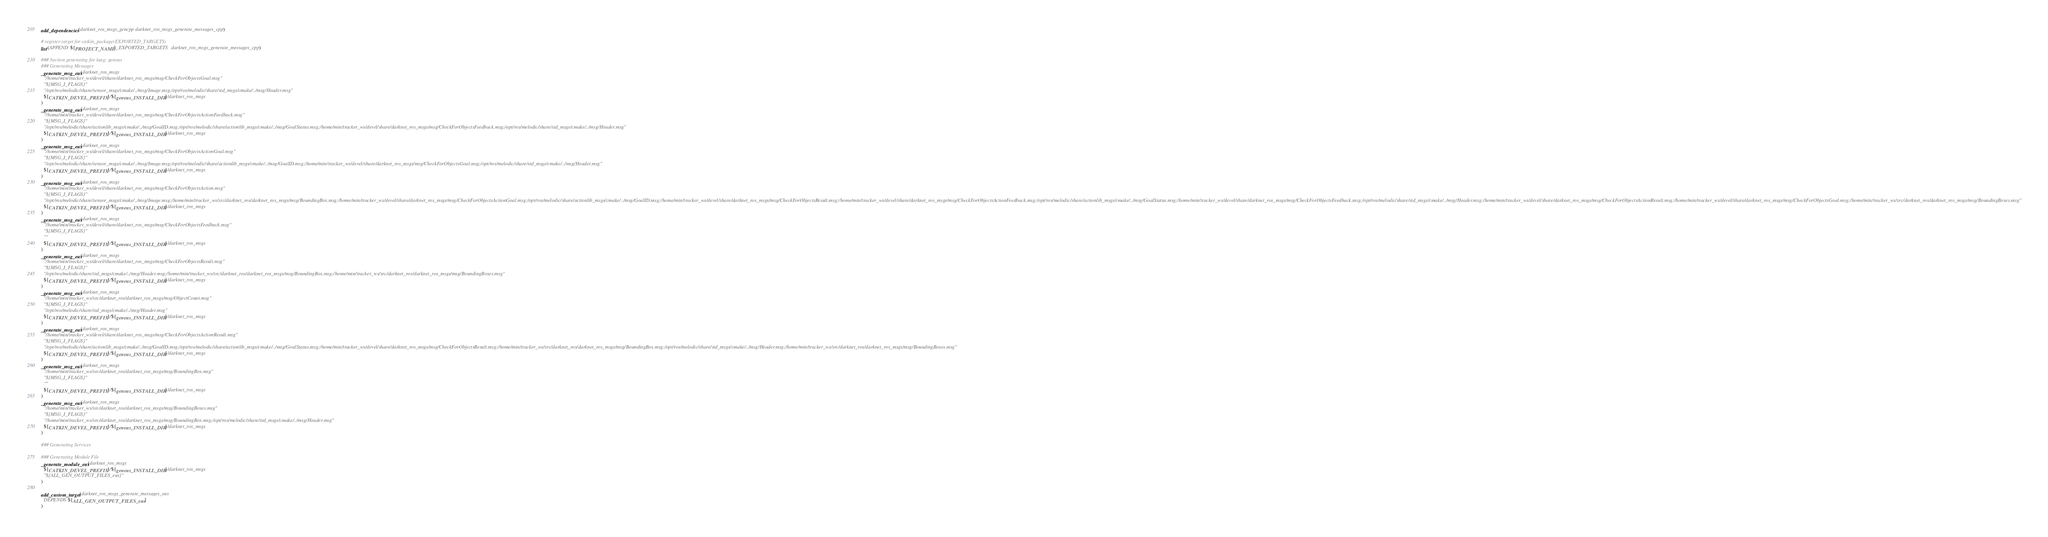Convert code to text. <code><loc_0><loc_0><loc_500><loc_500><_CMake_>add_dependencies(darknet_ros_msgs_gencpp darknet_ros_msgs_generate_messages_cpp)

# register target for catkin_package(EXPORTED_TARGETS)
list(APPEND ${PROJECT_NAME}_EXPORTED_TARGETS darknet_ros_msgs_generate_messages_cpp)

### Section generating for lang: geneus
### Generating Messages
_generate_msg_eus(darknet_ros_msgs
  "/home/min/tracker_ws/devel/share/darknet_ros_msgs/msg/CheckForObjectsGoal.msg"
  "${MSG_I_FLAGS}"
  "/opt/ros/melodic/share/sensor_msgs/cmake/../msg/Image.msg;/opt/ros/melodic/share/std_msgs/cmake/../msg/Header.msg"
  ${CATKIN_DEVEL_PREFIX}/${geneus_INSTALL_DIR}/darknet_ros_msgs
)
_generate_msg_eus(darknet_ros_msgs
  "/home/min/tracker_ws/devel/share/darknet_ros_msgs/msg/CheckForObjectsActionFeedback.msg"
  "${MSG_I_FLAGS}"
  "/opt/ros/melodic/share/actionlib_msgs/cmake/../msg/GoalID.msg;/opt/ros/melodic/share/actionlib_msgs/cmake/../msg/GoalStatus.msg;/home/min/tracker_ws/devel/share/darknet_ros_msgs/msg/CheckForObjectsFeedback.msg;/opt/ros/melodic/share/std_msgs/cmake/../msg/Header.msg"
  ${CATKIN_DEVEL_PREFIX}/${geneus_INSTALL_DIR}/darknet_ros_msgs
)
_generate_msg_eus(darknet_ros_msgs
  "/home/min/tracker_ws/devel/share/darknet_ros_msgs/msg/CheckForObjectsActionGoal.msg"
  "${MSG_I_FLAGS}"
  "/opt/ros/melodic/share/sensor_msgs/cmake/../msg/Image.msg;/opt/ros/melodic/share/actionlib_msgs/cmake/../msg/GoalID.msg;/home/min/tracker_ws/devel/share/darknet_ros_msgs/msg/CheckForObjectsGoal.msg;/opt/ros/melodic/share/std_msgs/cmake/../msg/Header.msg"
  ${CATKIN_DEVEL_PREFIX}/${geneus_INSTALL_DIR}/darknet_ros_msgs
)
_generate_msg_eus(darknet_ros_msgs
  "/home/min/tracker_ws/devel/share/darknet_ros_msgs/msg/CheckForObjectsAction.msg"
  "${MSG_I_FLAGS}"
  "/opt/ros/melodic/share/sensor_msgs/cmake/../msg/Image.msg;/home/min/tracker_ws/src/darknet_ros/darknet_ros_msgs/msg/BoundingBox.msg;/home/min/tracker_ws/devel/share/darknet_ros_msgs/msg/CheckForObjectsActionGoal.msg;/opt/ros/melodic/share/actionlib_msgs/cmake/../msg/GoalID.msg;/home/min/tracker_ws/devel/share/darknet_ros_msgs/msg/CheckForObjectsResult.msg;/home/min/tracker_ws/devel/share/darknet_ros_msgs/msg/CheckForObjectsActionFeedback.msg;/opt/ros/melodic/share/actionlib_msgs/cmake/../msg/GoalStatus.msg;/home/min/tracker_ws/devel/share/darknet_ros_msgs/msg/CheckForObjectsFeedback.msg;/opt/ros/melodic/share/std_msgs/cmake/../msg/Header.msg;/home/min/tracker_ws/devel/share/darknet_ros_msgs/msg/CheckForObjectsActionResult.msg;/home/min/tracker_ws/devel/share/darknet_ros_msgs/msg/CheckForObjectsGoal.msg;/home/min/tracker_ws/src/darknet_ros/darknet_ros_msgs/msg/BoundingBoxes.msg"
  ${CATKIN_DEVEL_PREFIX}/${geneus_INSTALL_DIR}/darknet_ros_msgs
)
_generate_msg_eus(darknet_ros_msgs
  "/home/min/tracker_ws/devel/share/darknet_ros_msgs/msg/CheckForObjectsFeedback.msg"
  "${MSG_I_FLAGS}"
  ""
  ${CATKIN_DEVEL_PREFIX}/${geneus_INSTALL_DIR}/darknet_ros_msgs
)
_generate_msg_eus(darknet_ros_msgs
  "/home/min/tracker_ws/devel/share/darknet_ros_msgs/msg/CheckForObjectsResult.msg"
  "${MSG_I_FLAGS}"
  "/opt/ros/melodic/share/std_msgs/cmake/../msg/Header.msg;/home/min/tracker_ws/src/darknet_ros/darknet_ros_msgs/msg/BoundingBox.msg;/home/min/tracker_ws/src/darknet_ros/darknet_ros_msgs/msg/BoundingBoxes.msg"
  ${CATKIN_DEVEL_PREFIX}/${geneus_INSTALL_DIR}/darknet_ros_msgs
)
_generate_msg_eus(darknet_ros_msgs
  "/home/min/tracker_ws/src/darknet_ros/darknet_ros_msgs/msg/ObjectCount.msg"
  "${MSG_I_FLAGS}"
  "/opt/ros/melodic/share/std_msgs/cmake/../msg/Header.msg"
  ${CATKIN_DEVEL_PREFIX}/${geneus_INSTALL_DIR}/darknet_ros_msgs
)
_generate_msg_eus(darknet_ros_msgs
  "/home/min/tracker_ws/devel/share/darknet_ros_msgs/msg/CheckForObjectsActionResult.msg"
  "${MSG_I_FLAGS}"
  "/opt/ros/melodic/share/actionlib_msgs/cmake/../msg/GoalID.msg;/opt/ros/melodic/share/actionlib_msgs/cmake/../msg/GoalStatus.msg;/home/min/tracker_ws/devel/share/darknet_ros_msgs/msg/CheckForObjectsResult.msg;/home/min/tracker_ws/src/darknet_ros/darknet_ros_msgs/msg/BoundingBox.msg;/opt/ros/melodic/share/std_msgs/cmake/../msg/Header.msg;/home/min/tracker_ws/src/darknet_ros/darknet_ros_msgs/msg/BoundingBoxes.msg"
  ${CATKIN_DEVEL_PREFIX}/${geneus_INSTALL_DIR}/darknet_ros_msgs
)
_generate_msg_eus(darknet_ros_msgs
  "/home/min/tracker_ws/src/darknet_ros/darknet_ros_msgs/msg/BoundingBox.msg"
  "${MSG_I_FLAGS}"
  ""
  ${CATKIN_DEVEL_PREFIX}/${geneus_INSTALL_DIR}/darknet_ros_msgs
)
_generate_msg_eus(darknet_ros_msgs
  "/home/min/tracker_ws/src/darknet_ros/darknet_ros_msgs/msg/BoundingBoxes.msg"
  "${MSG_I_FLAGS}"
  "/home/min/tracker_ws/src/darknet_ros/darknet_ros_msgs/msg/BoundingBox.msg;/opt/ros/melodic/share/std_msgs/cmake/../msg/Header.msg"
  ${CATKIN_DEVEL_PREFIX}/${geneus_INSTALL_DIR}/darknet_ros_msgs
)

### Generating Services

### Generating Module File
_generate_module_eus(darknet_ros_msgs
  ${CATKIN_DEVEL_PREFIX}/${geneus_INSTALL_DIR}/darknet_ros_msgs
  "${ALL_GEN_OUTPUT_FILES_eus}"
)

add_custom_target(darknet_ros_msgs_generate_messages_eus
  DEPENDS ${ALL_GEN_OUTPUT_FILES_eus}
)</code> 